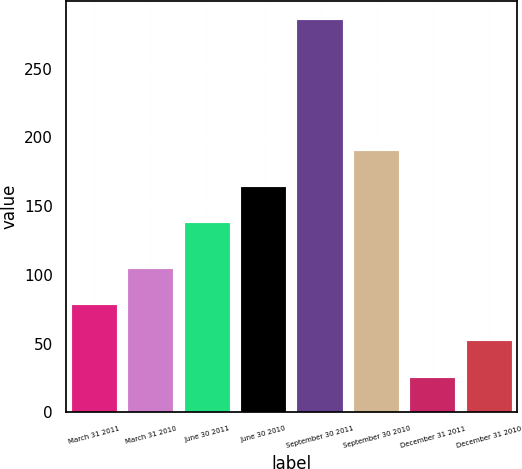Convert chart. <chart><loc_0><loc_0><loc_500><loc_500><bar_chart><fcel>March 31 2011<fcel>March 31 2010<fcel>June 30 2011<fcel>June 30 2010<fcel>September 30 2011<fcel>September 30 2010<fcel>December 31 2011<fcel>December 31 2010<nl><fcel>78<fcel>104<fcel>138<fcel>164<fcel>285<fcel>190<fcel>25<fcel>52<nl></chart> 